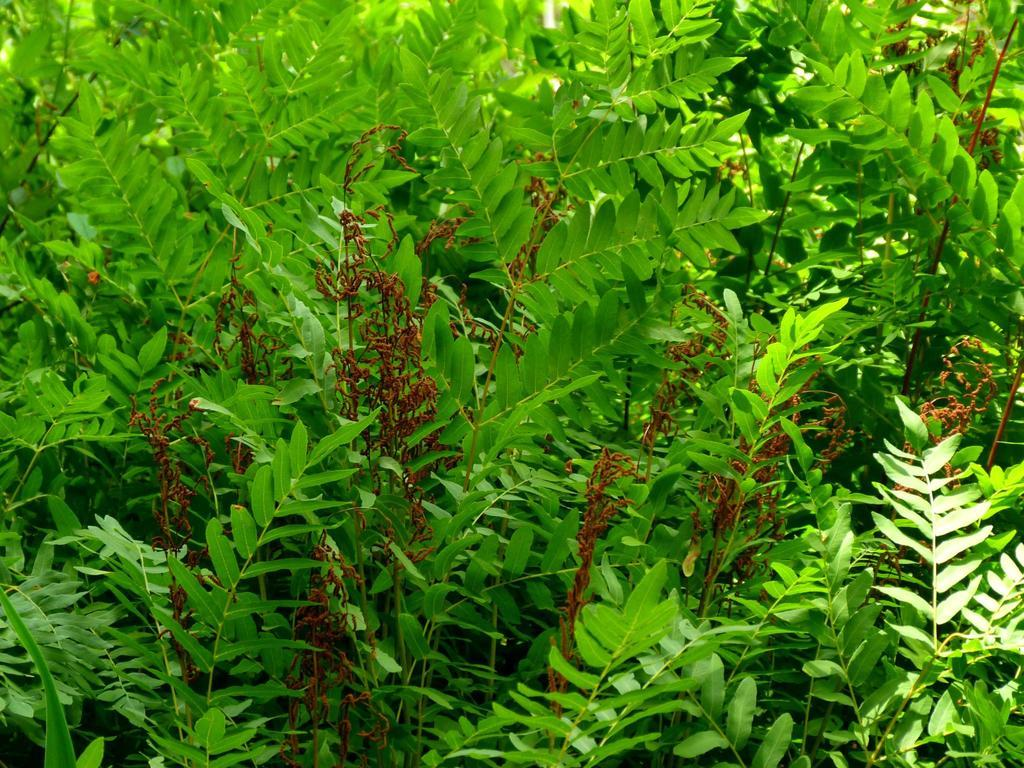What type of plants can be seen in the image? There are green plants in the image. What is the condition of some of the leaves on the plants? Some of the leaves on the plants are dry and brown. What type of honey is being produced by the plants in the image? There is no honey production mentioned or visible in the image; it features green plants with some dry and brown leaves. What type of steel structure can be seen supporting the plants in the image? There is no steel structure present in the image; it only features green plants with some dry and brown leaves. 